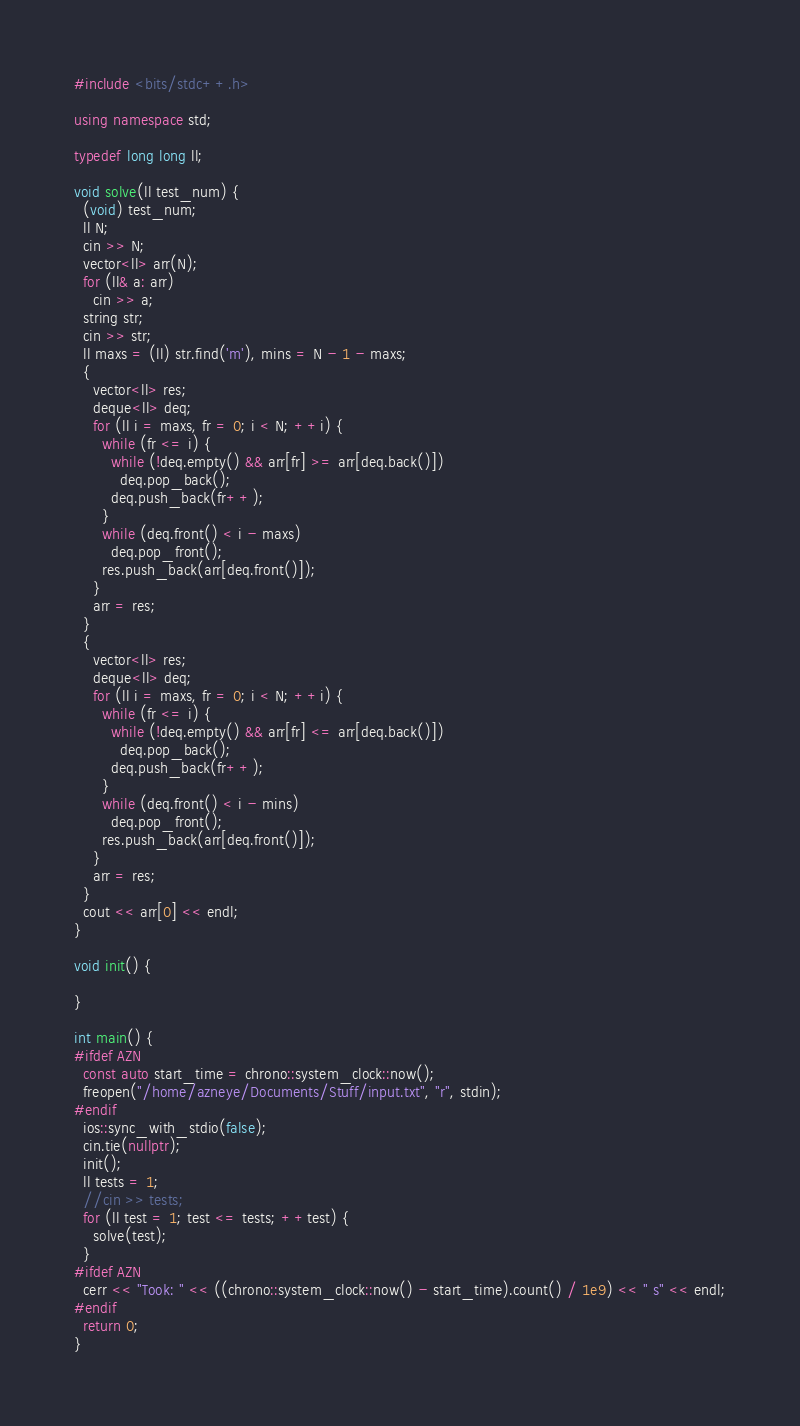Convert code to text. <code><loc_0><loc_0><loc_500><loc_500><_C++_>#include <bits/stdc++.h>

using namespace std;

typedef long long ll;

void solve(ll test_num) {
  (void) test_num;
  ll N;
  cin >> N;
  vector<ll> arr(N);
  for (ll& a: arr)
    cin >> a;
  string str;
  cin >> str;
  ll maxs = (ll) str.find('m'), mins = N - 1 - maxs;
  {
    vector<ll> res;
    deque<ll> deq;
    for (ll i = maxs, fr = 0; i < N; ++i) {
      while (fr <= i) {
        while (!deq.empty() && arr[fr] >= arr[deq.back()])
          deq.pop_back();
        deq.push_back(fr++);
      }
      while (deq.front() < i - maxs)
        deq.pop_front();
      res.push_back(arr[deq.front()]);
    }
    arr = res;
  }
  {
    vector<ll> res;
    deque<ll> deq;
    for (ll i = maxs, fr = 0; i < N; ++i) {
      while (fr <= i) {
        while (!deq.empty() && arr[fr] <= arr[deq.back()])
          deq.pop_back();
        deq.push_back(fr++);
      }
      while (deq.front() < i - mins)
        deq.pop_front();
      res.push_back(arr[deq.front()]);
    }
    arr = res;
  }
  cout << arr[0] << endl;
}

void init() {

}

int main() {
#ifdef AZN
  const auto start_time = chrono::system_clock::now();
  freopen("/home/azneye/Documents/Stuff/input.txt", "r", stdin);
#endif
  ios::sync_with_stdio(false);
  cin.tie(nullptr);
  init();
  ll tests = 1;
  //cin >> tests;
  for (ll test = 1; test <= tests; ++test) {
    solve(test);
  }
#ifdef AZN
  cerr << "Took: " << ((chrono::system_clock::now() - start_time).count() / 1e9) << " s" << endl;
#endif
  return 0;
}</code> 